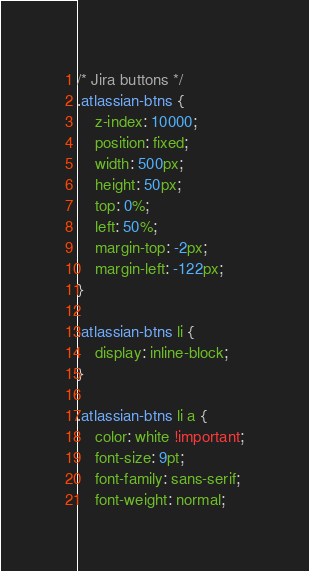<code> <loc_0><loc_0><loc_500><loc_500><_CSS_>/* Jira buttons */
.atlassian-btns {
    z-index: 10000;
    position: fixed;
    width: 500px;
    height: 50px;
    top: 0%;
    left: 50%;
    margin-top: -2px;
    margin-left: -122px;
}

.atlassian-btns li {
    display: inline-block;
}

.atlassian-btns li a {
    color: white !important;
    font-size: 9pt;
    font-family: sans-serif;
    font-weight: normal;</code> 